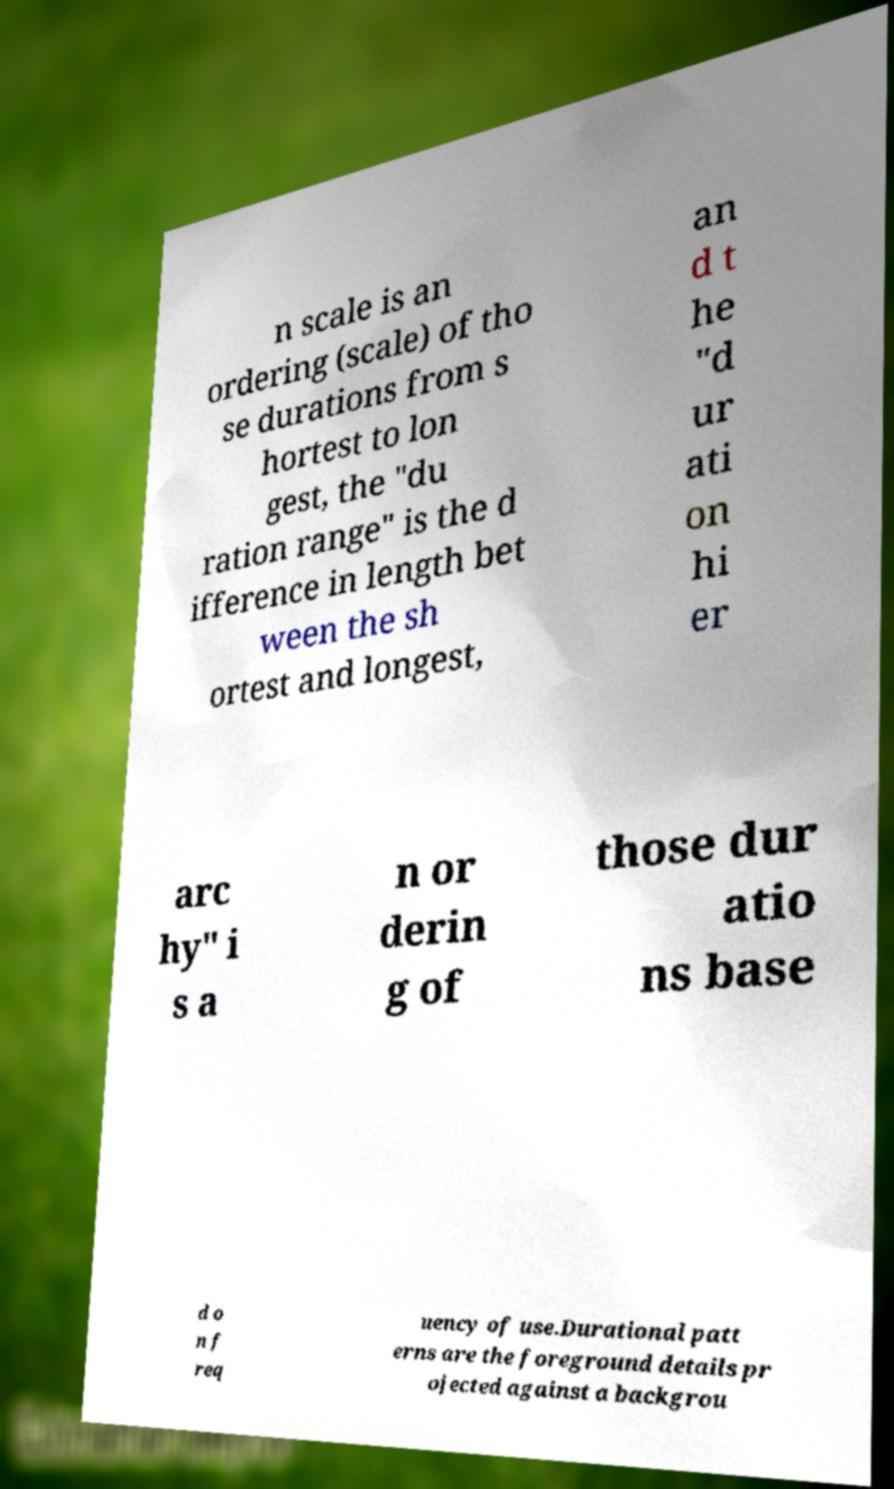Please read and relay the text visible in this image. What does it say? n scale is an ordering (scale) of tho se durations from s hortest to lon gest, the "du ration range" is the d ifference in length bet ween the sh ortest and longest, an d t he "d ur ati on hi er arc hy" i s a n or derin g of those dur atio ns base d o n f req uency of use.Durational patt erns are the foreground details pr ojected against a backgrou 